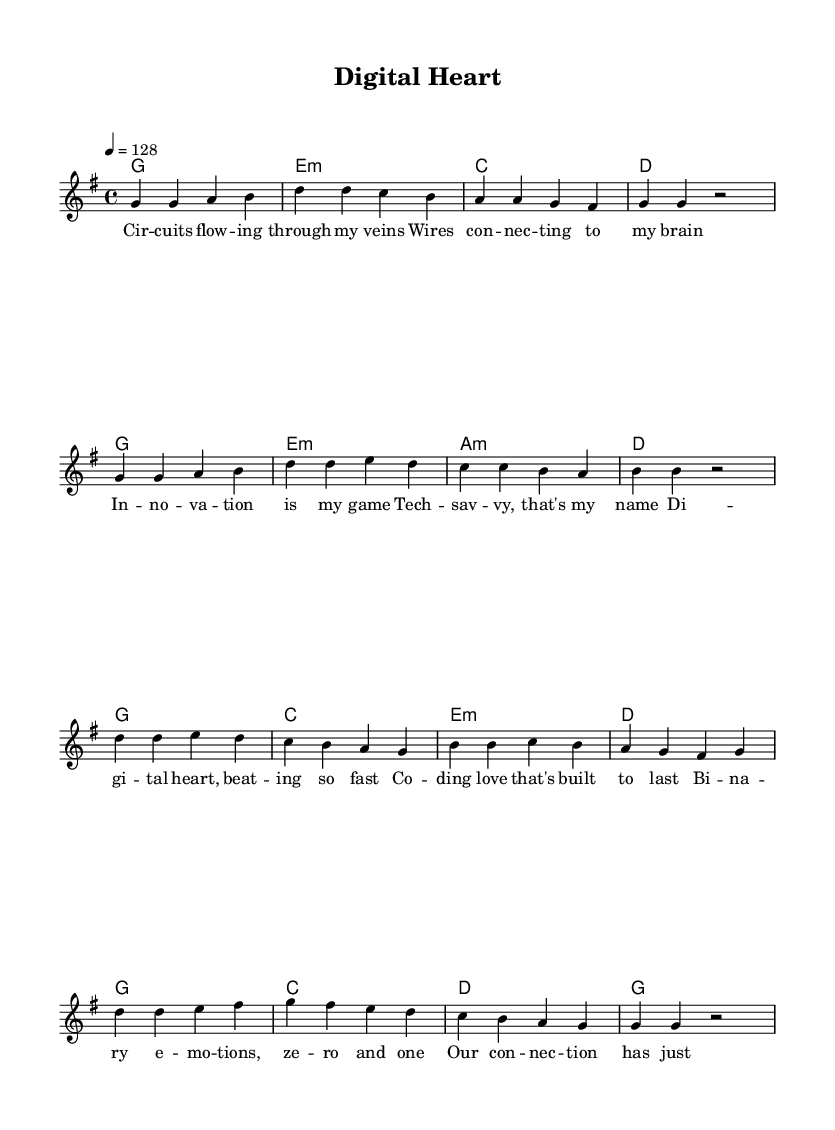What is the key signature of this music? The key signature is G major, which has one sharp (F#). You can determine this from the global settings at the beginning of the sheet music.
Answer: G major What is the time signature of this music? The time signature is 4/4, as indicated in the global settings section of the sheet music. This means there are four beats in each measure.
Answer: 4/4 What is the tempo of this piece? The tempo is set at 128 beats per minute, as specified in the tempo marking in the global settings.
Answer: 128 How many measures are in the verse section? The verse section consists of 8 measures, as counted directly from the melody lines that are marked as the verse.
Answer: 8 What unique theme is explored in the lyrics? The lyrics explore themes of technology and connection, as evidenced by phrases like "Circuits flowing through my veins" and "Coding love that's built to last."
Answer: Technology and connection What type of emotions are described in the chorus lyrics? The emotions described in the chorus lyrics include binary emotions, specifically referring to "zero and one," which references digital themes commonly found in K-Pop.
Answer: Binary emotions 